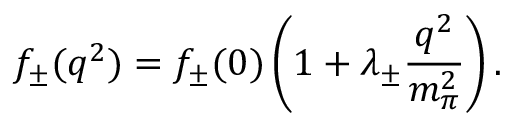Convert formula to latex. <formula><loc_0><loc_0><loc_500><loc_500>f _ { \pm } ( q ^ { 2 } ) = f _ { \pm } ( 0 ) \left ( 1 + \lambda _ { \pm } \frac { q ^ { 2 } } { m _ { \pi } ^ { 2 } } \right ) .</formula> 